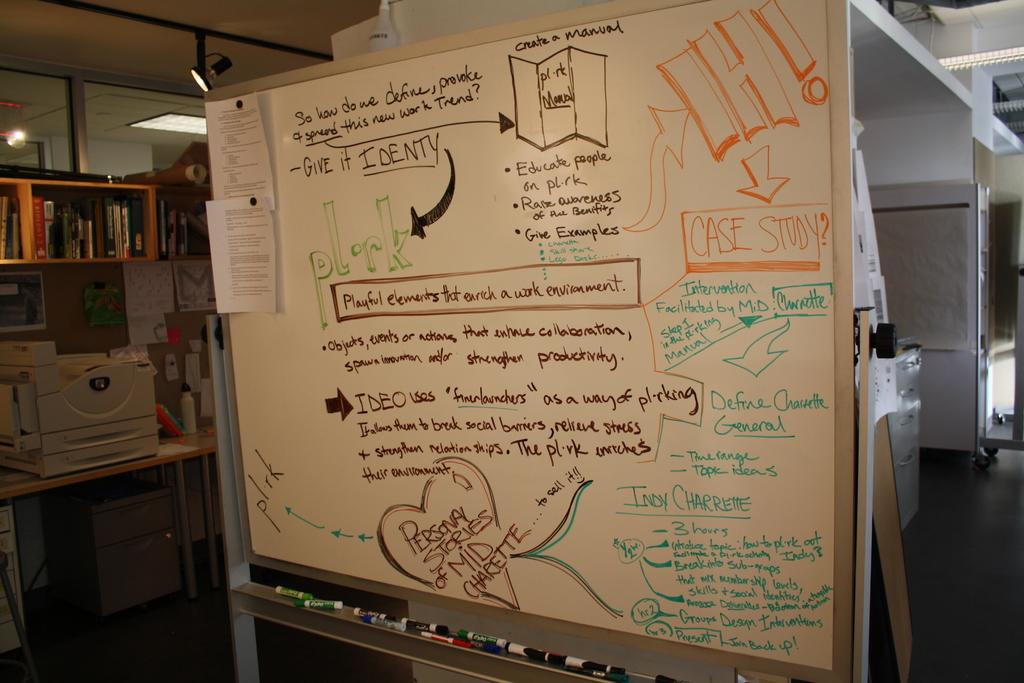What's the identify name?
Offer a terse response. Pl rk. 